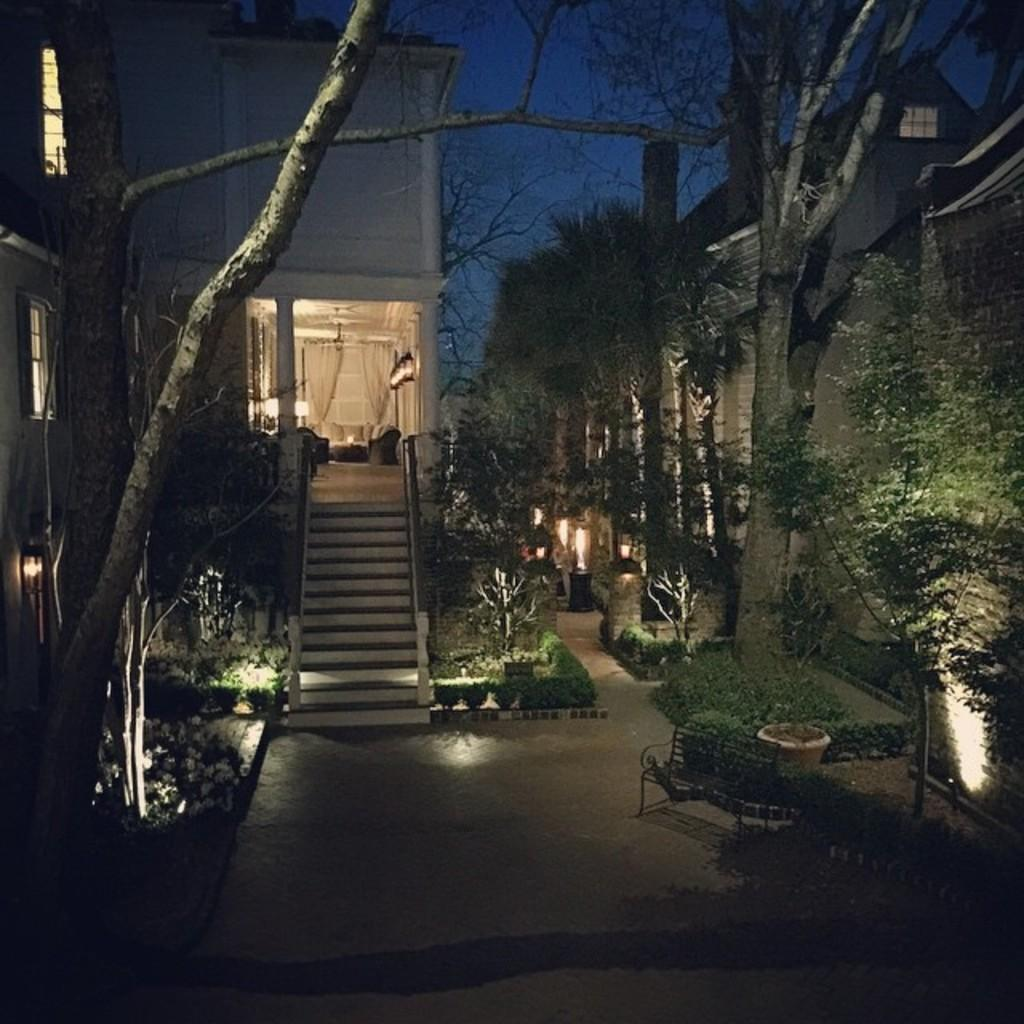What is located on the ground in the image? There is a bench on the ground in the image. What type of vegetation can be seen in the image? There are plants and trees in the image. What architectural features are present in the image? There are buildings with windows and steps in the image. What type of window treatment is visible in the image? There are curtains in the image. What part of the natural environment is visible in the background of the image? The sky is visible in the background of the image. What time of day is represented by the hour in the image? There is no hour present in the image, as it is a visual representation and not a clock or timepiece. How many boys are visible in the image? There are no boys present in the image. What type of oil is being used in the image? There is no oil present in the image. 